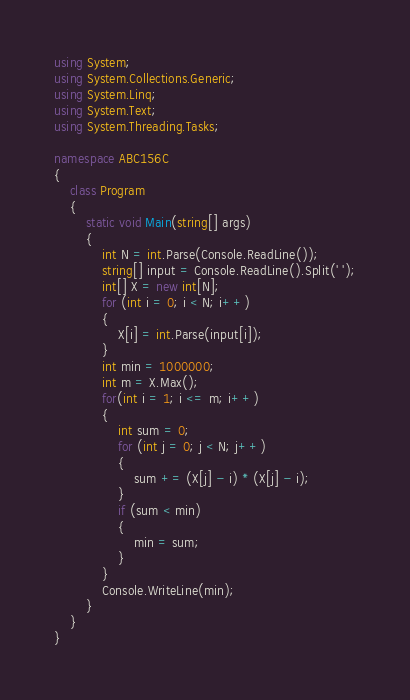Convert code to text. <code><loc_0><loc_0><loc_500><loc_500><_C#_>using System;
using System.Collections.Generic;
using System.Linq;
using System.Text;
using System.Threading.Tasks;

namespace ABC156C
{
    class Program
    {
        static void Main(string[] args)
        {
            int N = int.Parse(Console.ReadLine());
            string[] input = Console.ReadLine().Split(' ');
            int[] X = new int[N];
            for (int i = 0; i < N; i++)
            {
                X[i] = int.Parse(input[i]);
            }
            int min = 1000000;
            int m = X.Max();
            for(int i = 1; i <= m; i++)
            {
                int sum = 0;
                for (int j = 0; j < N; j++)
                {
                    sum += (X[j] - i) * (X[j] - i);
                }
                if (sum < min)
                {
                    min = sum;
                }
            }
            Console.WriteLine(min);
        }
    }
}
</code> 